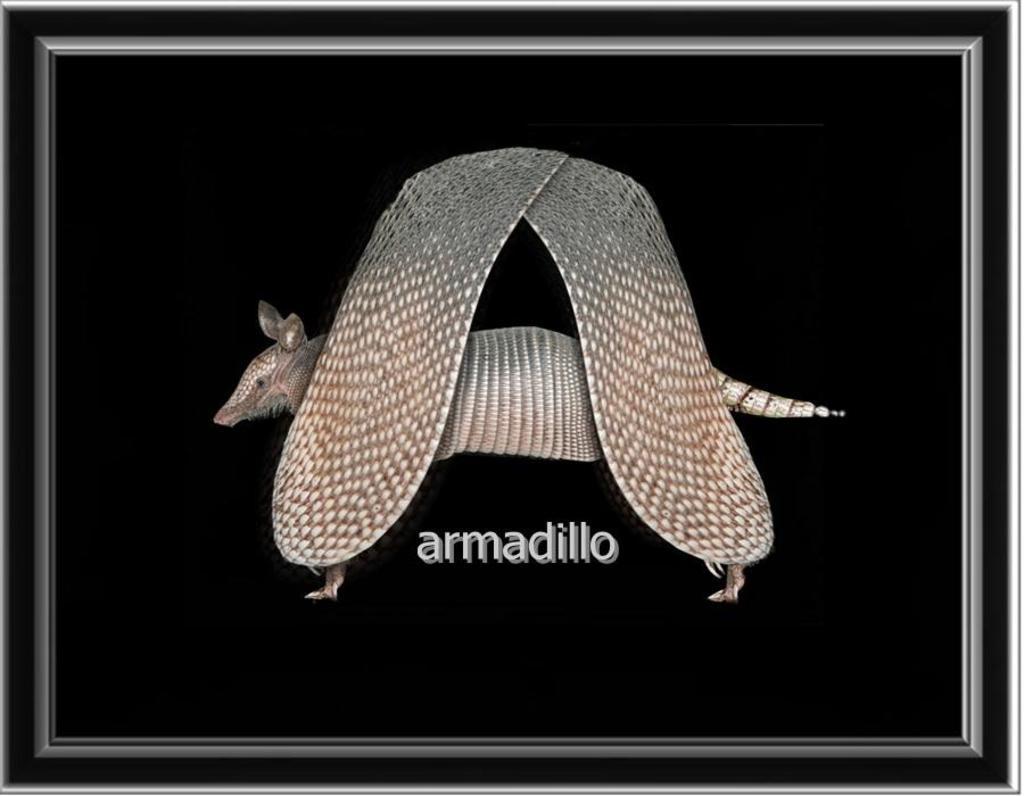In one or two sentences, can you explain what this image depicts? In this picture I can see the photo frame. I can see the animal. 